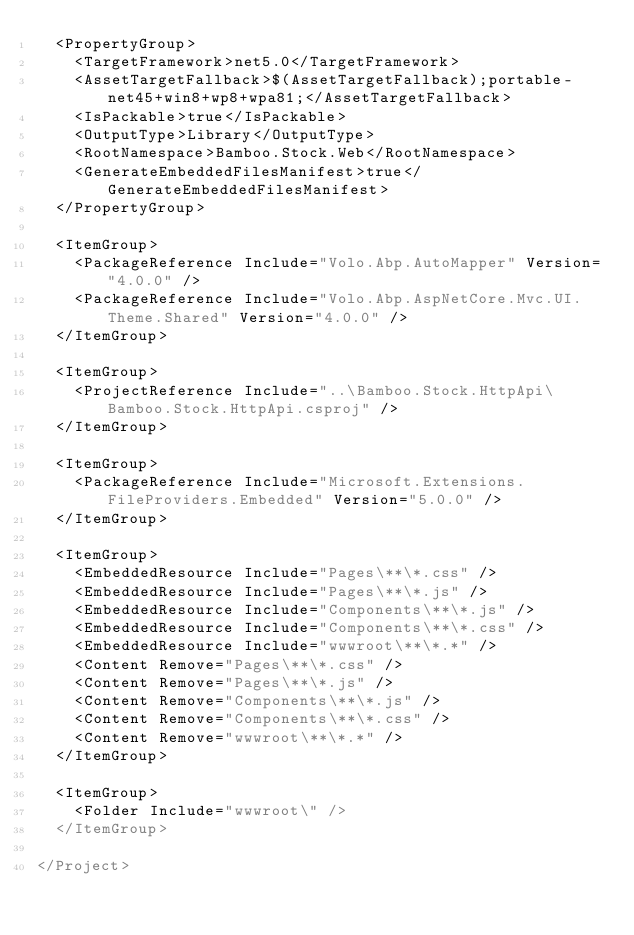<code> <loc_0><loc_0><loc_500><loc_500><_XML_>  <PropertyGroup>
    <TargetFramework>net5.0</TargetFramework>
    <AssetTargetFallback>$(AssetTargetFallback);portable-net45+win8+wp8+wpa81;</AssetTargetFallback>
    <IsPackable>true</IsPackable>
    <OutputType>Library</OutputType>
    <RootNamespace>Bamboo.Stock.Web</RootNamespace>
    <GenerateEmbeddedFilesManifest>true</GenerateEmbeddedFilesManifest>
  </PropertyGroup>

  <ItemGroup>
    <PackageReference Include="Volo.Abp.AutoMapper" Version="4.0.0" />
    <PackageReference Include="Volo.Abp.AspNetCore.Mvc.UI.Theme.Shared" Version="4.0.0" />
  </ItemGroup>

  <ItemGroup>
    <ProjectReference Include="..\Bamboo.Stock.HttpApi\Bamboo.Stock.HttpApi.csproj" />
  </ItemGroup>

  <ItemGroup>
    <PackageReference Include="Microsoft.Extensions.FileProviders.Embedded" Version="5.0.0" />
  </ItemGroup>

  <ItemGroup>
    <EmbeddedResource Include="Pages\**\*.css" />
    <EmbeddedResource Include="Pages\**\*.js" />
    <EmbeddedResource Include="Components\**\*.js" />
    <EmbeddedResource Include="Components\**\*.css" />
    <EmbeddedResource Include="wwwroot\**\*.*" />
    <Content Remove="Pages\**\*.css" />
    <Content Remove="Pages\**\*.js" />
    <Content Remove="Components\**\*.js" />
    <Content Remove="Components\**\*.css" />
    <Content Remove="wwwroot\**\*.*" />
  </ItemGroup>

  <ItemGroup>
    <Folder Include="wwwroot\" />
  </ItemGroup>

</Project>
</code> 